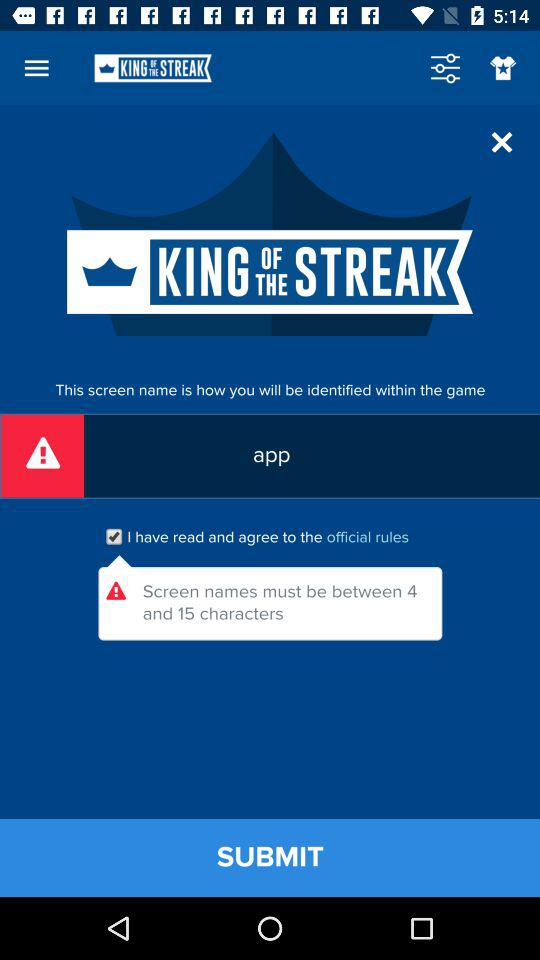How many characters should the screen name contain? The screen name should contain 4 to 15 characters. 